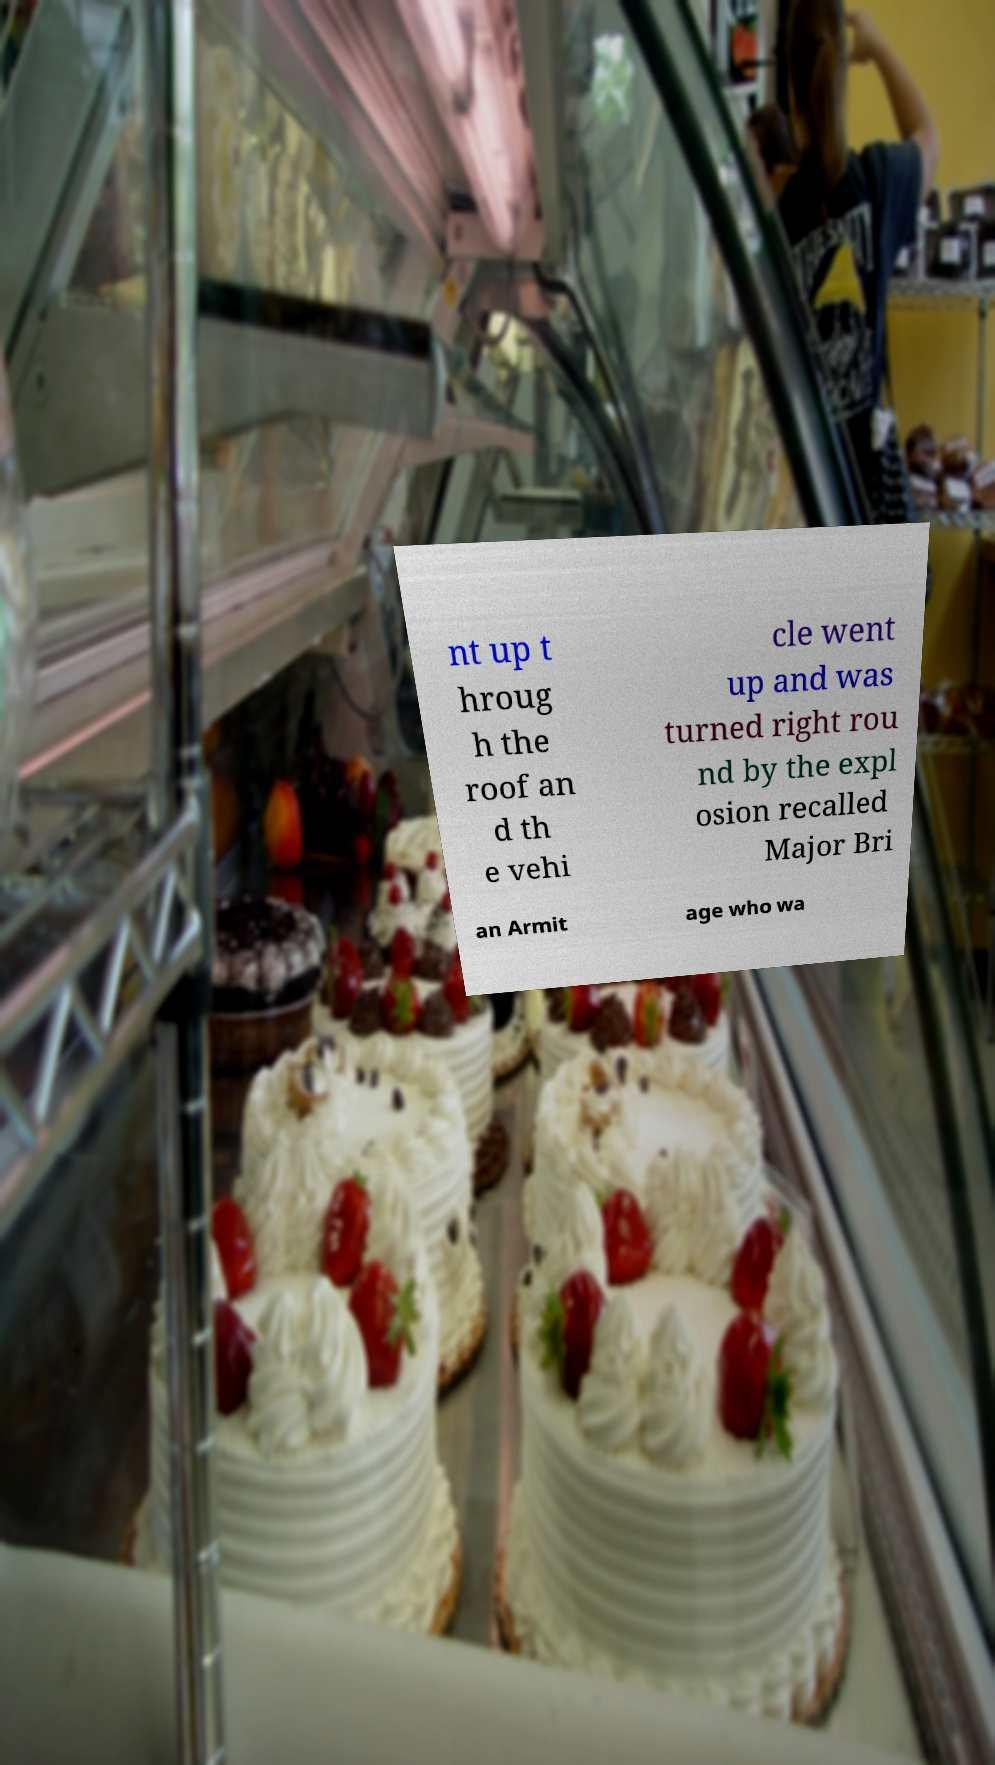Please read and relay the text visible in this image. What does it say? nt up t hroug h the roof an d th e vehi cle went up and was turned right rou nd by the expl osion recalled Major Bri an Armit age who wa 